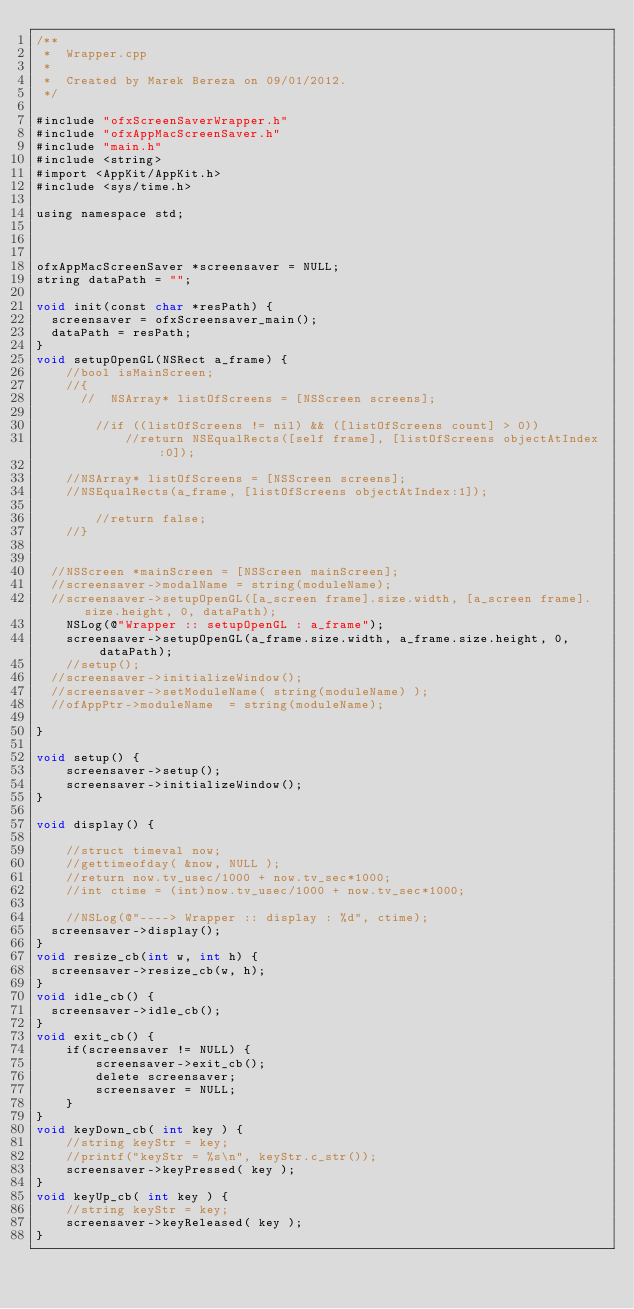Convert code to text. <code><loc_0><loc_0><loc_500><loc_500><_ObjectiveC_>/**
 *  Wrapper.cpp
 *
 *  Created by Marek Bereza on 09/01/2012.
 */

#include "ofxScreenSaverWrapper.h"
#include "ofxAppMacScreenSaver.h"
#include "main.h"
#include <string>
#import <AppKit/AppKit.h>
#include <sys/time.h>

using namespace std;



ofxAppMacScreenSaver *screensaver = NULL;
string dataPath = "";

void init(const char *resPath) {
	screensaver = ofxScreensaver_main();
	dataPath = resPath;
}
void setupOpenGL(NSRect a_frame) {
    //bool isMainScreen;
    //{
      //  NSArray* listOfScreens = [NSScreen screens];
        
        //if ((listOfScreens != nil) && ([listOfScreens count] > 0))
            //return NSEqualRects([self frame], [listOfScreens objectAtIndex:0]);
    
    //NSArray* listOfScreens = [NSScreen screens];
    //NSEqualRects(a_frame, [listOfScreens objectAtIndex:1]);
        
        //return false;
    //}
    

	//NSScreen *mainScreen = [NSScreen mainScreen];
	//screensaver->modalName = string(moduleName);
	//screensaver->setupOpenGL([a_screen frame].size.width, [a_screen frame].size.height, 0, dataPath);
    NSLog(@"Wrapper :: setupOpenGL : a_frame");
    screensaver->setupOpenGL(a_frame.size.width, a_frame.size.height, 0, dataPath);
    //setup();
	//screensaver->initializeWindow();
	//screensaver->setModuleName( string(moduleName) );
	//ofAppPtr->moduleName  = string(moduleName);
	
}

void setup() {
    screensaver->setup();
    screensaver->initializeWindow();
}

void display() {
    
    //struct timeval now;
    //gettimeofday( &now, NULL );
    //return now.tv_usec/1000 + now.tv_sec*1000;
    //int ctime = (int)now.tv_usec/1000 + now.tv_sec*1000;
    
    //NSLog(@"----> Wrapper :: display : %d", ctime);
	screensaver->display();
}
void resize_cb(int w, int h) {
	screensaver->resize_cb(w, h);
}
void idle_cb() {
	screensaver->idle_cb();
}
void exit_cb() {
    if(screensaver != NULL) {
        screensaver->exit_cb();
        delete screensaver;
        screensaver = NULL;
    }
}
void keyDown_cb( int key ) {
    //string keyStr = key;
    //printf("keyStr = %s\n", keyStr.c_str());
    screensaver->keyPressed( key );
}
void keyUp_cb( int key ) {
    //string keyStr = key;
    screensaver->keyReleased( key );
}












</code> 